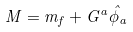Convert formula to latex. <formula><loc_0><loc_0><loc_500><loc_500>M = m _ { f } + G ^ { a } \hat { \phi } _ { a }</formula> 